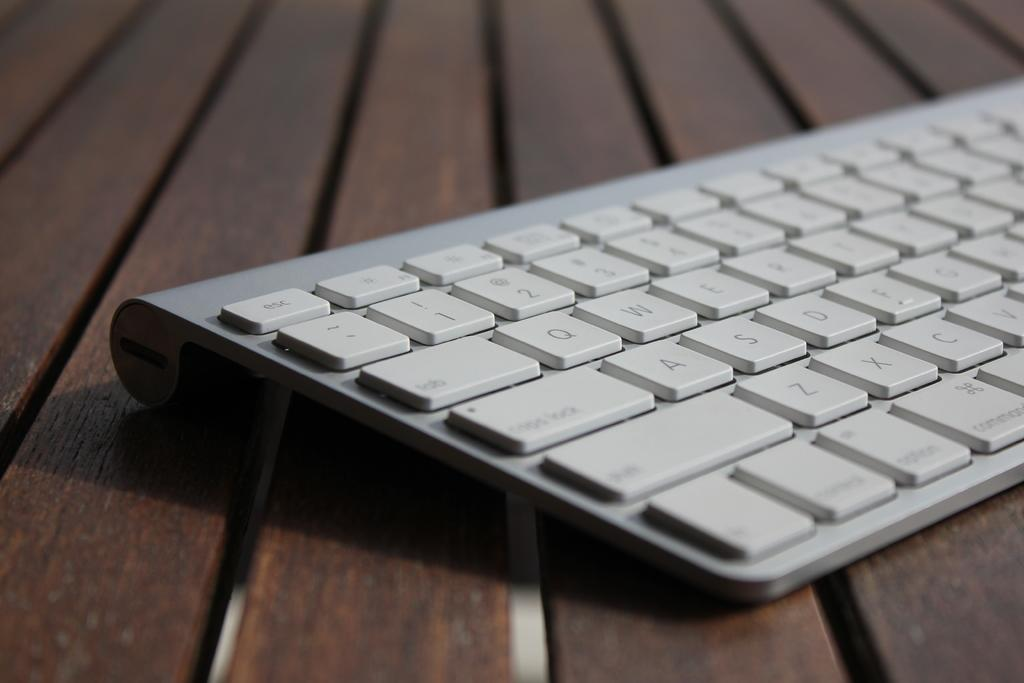<image>
Describe the image concisely. Apartial view of a grey computer keyboard, the escape button "ESC" is visible along with the left side of letters 